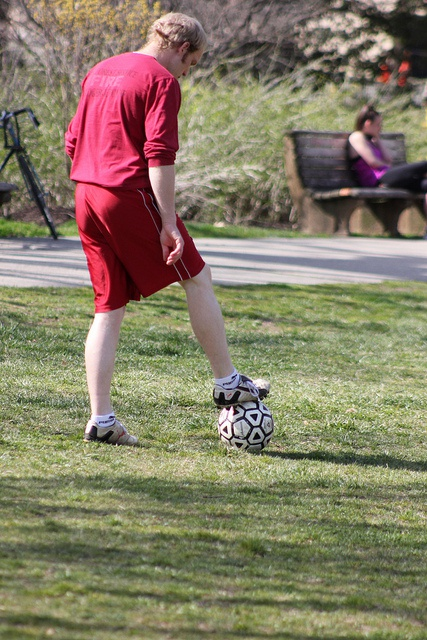Describe the objects in this image and their specific colors. I can see people in black, maroon, violet, gray, and darkgray tones, bench in black, gray, and tan tones, people in black, gray, purple, and brown tones, sports ball in black, darkgray, white, and gray tones, and bicycle in black, gray, and darkgreen tones in this image. 